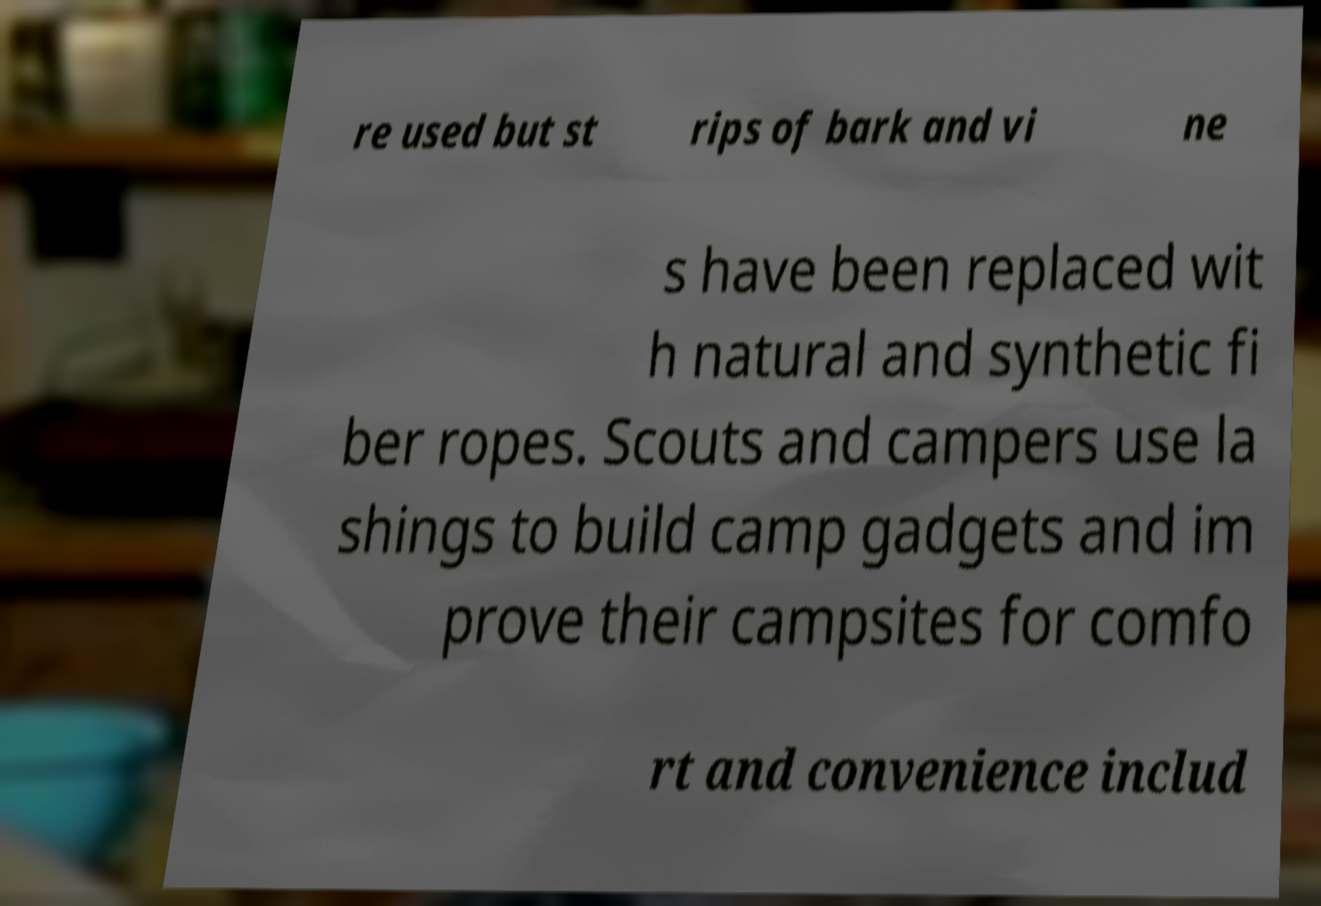There's text embedded in this image that I need extracted. Can you transcribe it verbatim? re used but st rips of bark and vi ne s have been replaced wit h natural and synthetic fi ber ropes. Scouts and campers use la shings to build camp gadgets and im prove their campsites for comfo rt and convenience includ 